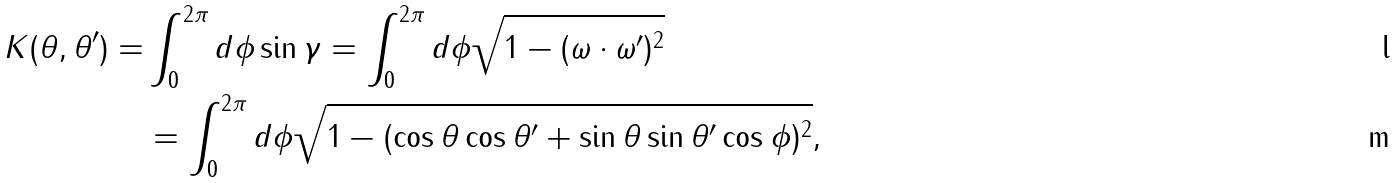<formula> <loc_0><loc_0><loc_500><loc_500>K ( \theta , \theta ^ { \prime } ) = & \int _ { 0 } ^ { 2 \pi } d \phi \sin \gamma = \int _ { 0 } ^ { 2 \pi } d \phi \sqrt { 1 - ( \omega \cdot \omega ^ { \prime } ) ^ { 2 } } \\ & = \int _ { 0 } ^ { 2 \pi } d \phi \sqrt { 1 - ( \cos \theta \cos \theta ^ { \prime } + \sin \theta \sin \theta ^ { \prime } \cos \phi ) ^ { 2 } } ,</formula> 